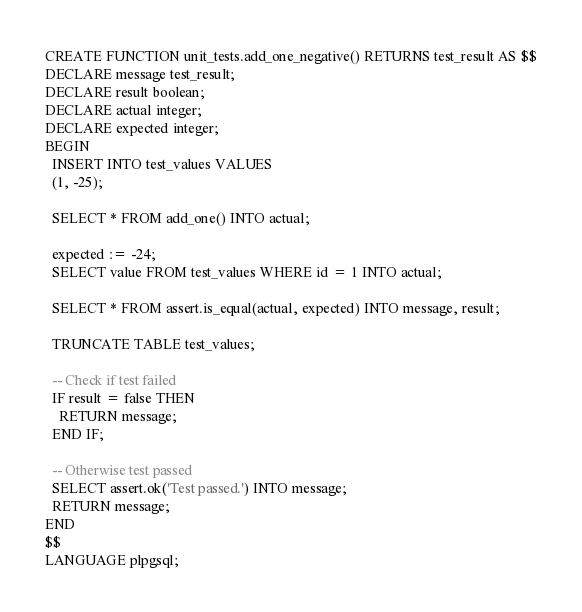Convert code to text. <code><loc_0><loc_0><loc_500><loc_500><_SQL_>CREATE FUNCTION unit_tests.add_one_negative() RETURNS test_result AS $$
DECLARE message test_result;
DECLARE result boolean;
DECLARE actual integer;
DECLARE expected integer;
BEGIN
  INSERT INTO test_values VALUES
  (1, -25);

  SELECT * FROM add_one() INTO actual;

  expected := -24;
  SELECT value FROM test_values WHERE id = 1 INTO actual;

  SELECT * FROM assert.is_equal(actual, expected) INTO message, result;

  TRUNCATE TABLE test_values;

  -- Check if test failed
  IF result = false THEN
    RETURN message;
  END IF;

  -- Otherwise test passed
  SELECT assert.ok('Test passed.') INTO message;
  RETURN message;
END
$$
LANGUAGE plpgsql;</code> 